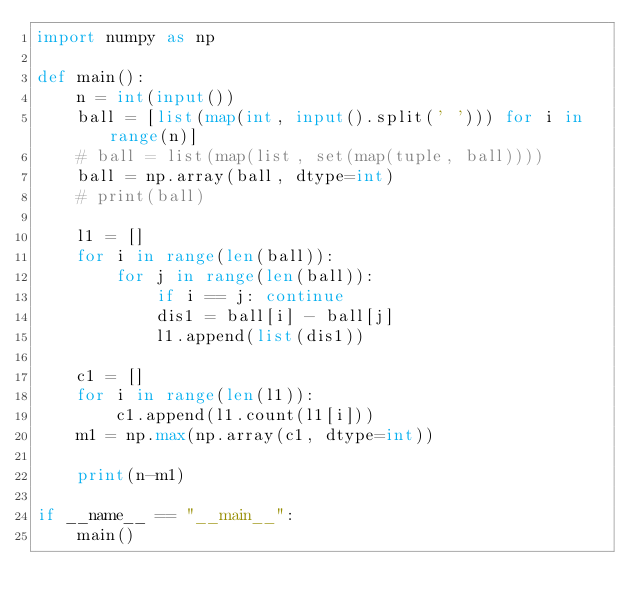<code> <loc_0><loc_0><loc_500><loc_500><_Python_>import numpy as np

def main():
    n = int(input())
    ball = [list(map(int, input().split(' '))) for i in range(n)]
    # ball = list(map(list, set(map(tuple, ball))))
    ball = np.array(ball, dtype=int)
    # print(ball)

    l1 = []
    for i in range(len(ball)):
        for j in range(len(ball)):
            if i == j: continue
            dis1 = ball[i] - ball[j]
            l1.append(list(dis1))

    c1 = []
    for i in range(len(l1)):
        c1.append(l1.count(l1[i]))
    m1 = np.max(np.array(c1, dtype=int))

    print(n-m1)

if __name__ == "__main__":
    main()</code> 